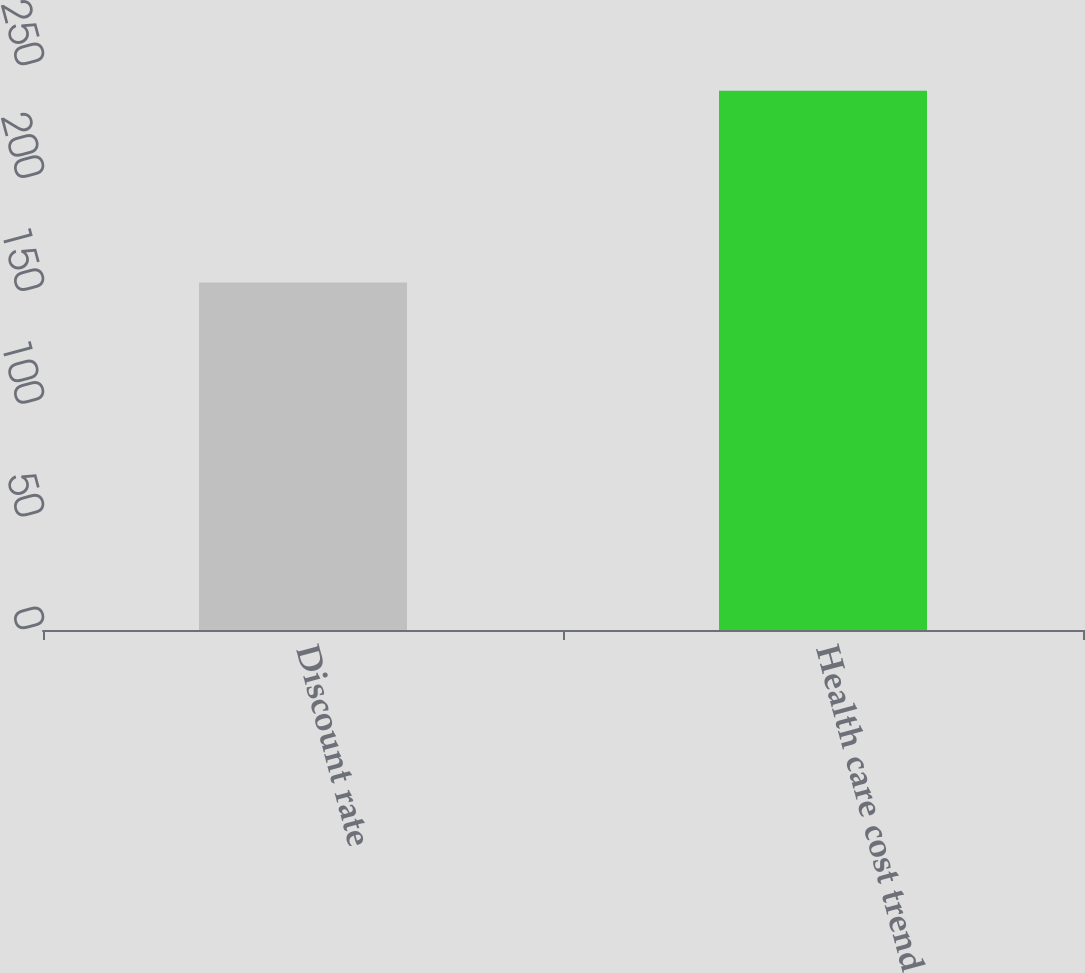Convert chart. <chart><loc_0><loc_0><loc_500><loc_500><bar_chart><fcel>Discount rate<fcel>Health care cost trend<nl><fcel>154<fcel>239<nl></chart> 